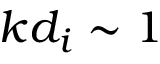Convert formula to latex. <formula><loc_0><loc_0><loc_500><loc_500>k d _ { i } \sim 1</formula> 